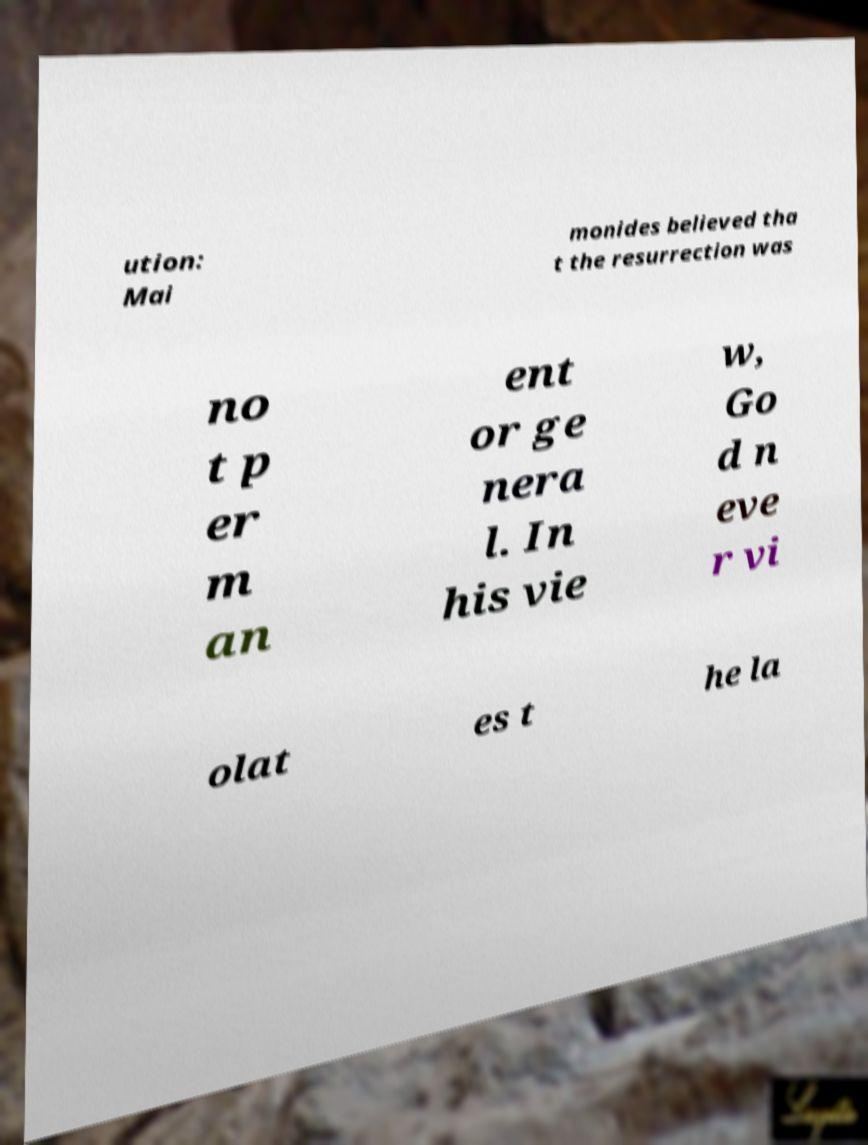Can you read and provide the text displayed in the image?This photo seems to have some interesting text. Can you extract and type it out for me? ution: Mai monides believed tha t the resurrection was no t p er m an ent or ge nera l. In his vie w, Go d n eve r vi olat es t he la 